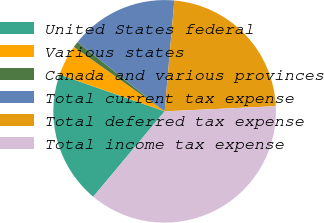<chart> <loc_0><loc_0><loc_500><loc_500><pie_chart><fcel>United States federal<fcel>Various states<fcel>Canada and various provinces<fcel>Total current tax expense<fcel>Total deferred tax expense<fcel>Total income tax expense<nl><fcel>19.28%<fcel>4.47%<fcel>0.87%<fcel>15.69%<fcel>22.88%<fcel>36.82%<nl></chart> 